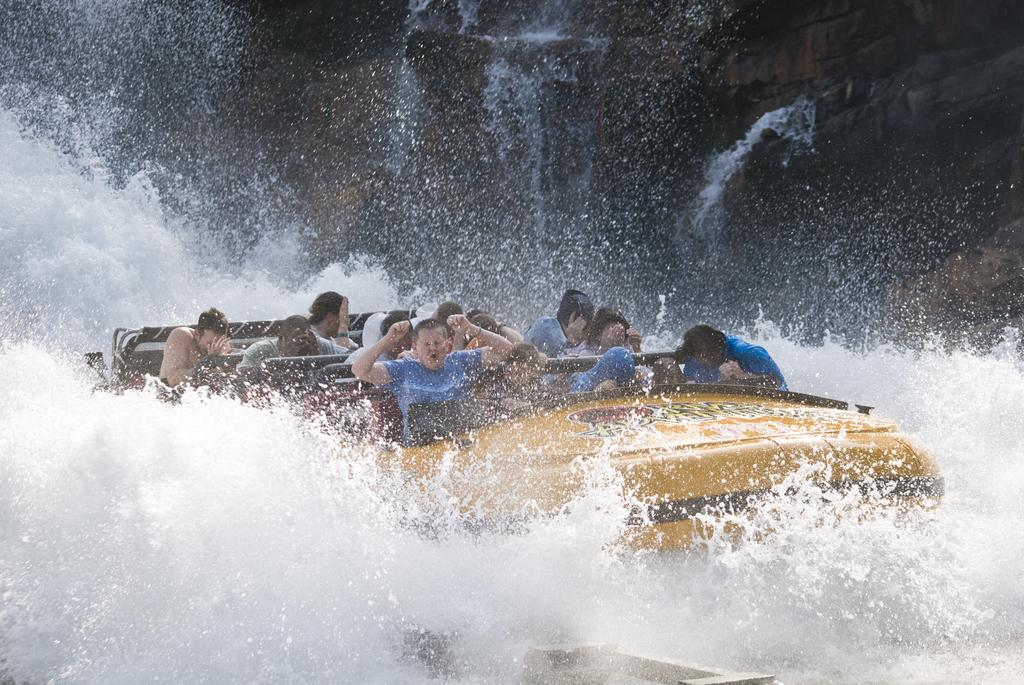What is the main subject of the image? The main subject of the image is a group of people. Where are the people located in the image? The people are sitting in a yellow color boat. What are the people wearing in the image? The people are wearing blue color t-shirts. What can be seen in the background of the image? There is water visible in the image. What type of office equipment can be seen in the image? There is no office equipment present in the image; it features a group of people sitting in a yellow boat on water. 